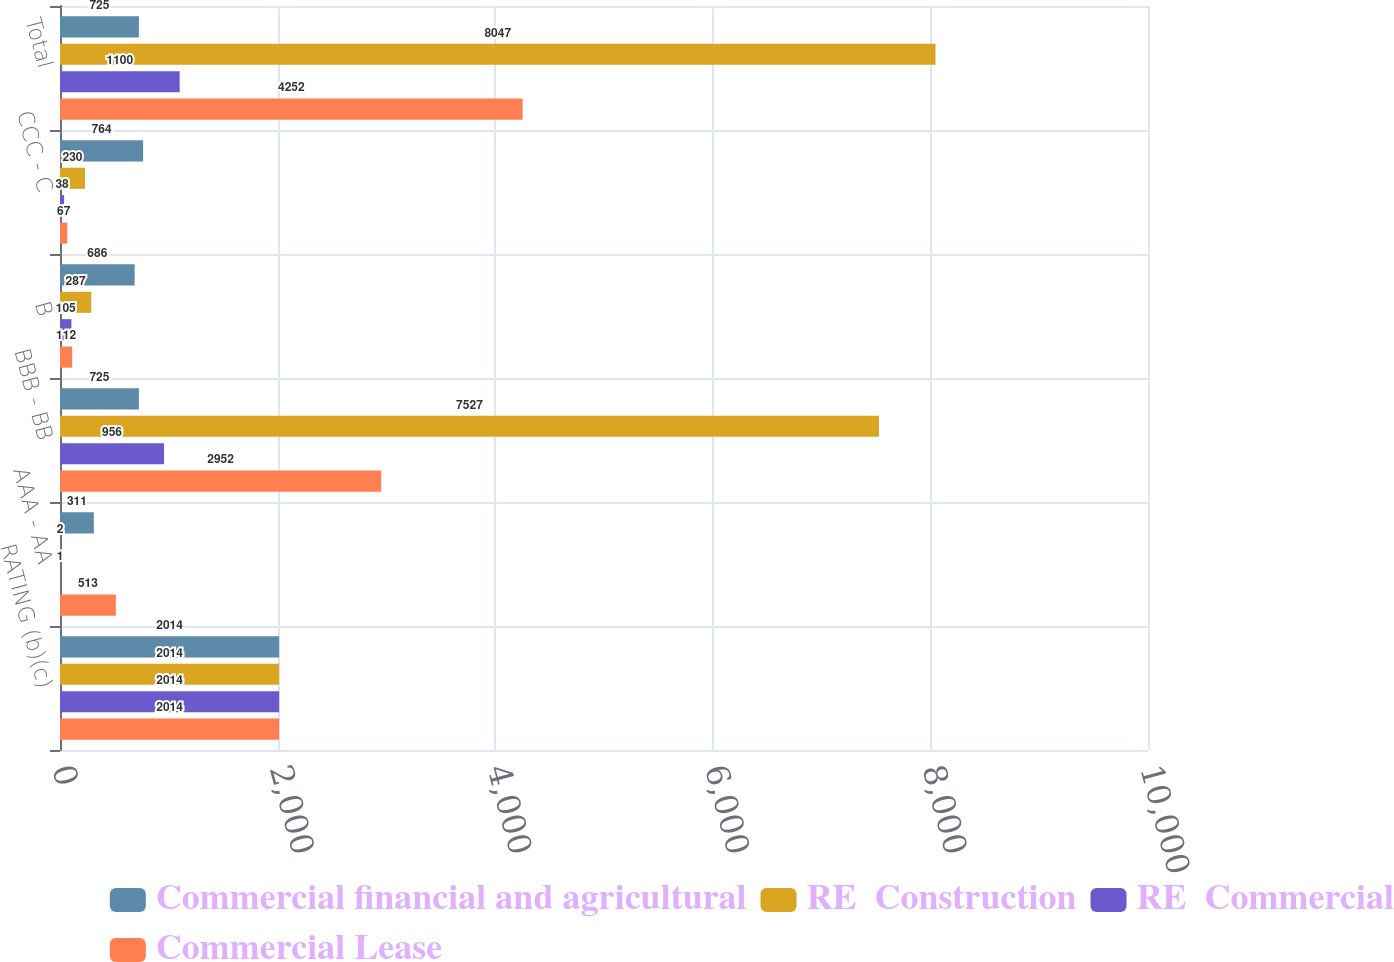<chart> <loc_0><loc_0><loc_500><loc_500><stacked_bar_chart><ecel><fcel>RATING (b)(c)<fcel>AAA - AA<fcel>BBB - BB<fcel>B<fcel>CCC - C<fcel>Total<nl><fcel>Commercial financial and agricultural<fcel>2014<fcel>311<fcel>725<fcel>686<fcel>764<fcel>725<nl><fcel>RE  Construction<fcel>2014<fcel>2<fcel>7527<fcel>287<fcel>230<fcel>8047<nl><fcel>RE  Commercial<fcel>2014<fcel>1<fcel>956<fcel>105<fcel>38<fcel>1100<nl><fcel>Commercial Lease<fcel>2014<fcel>513<fcel>2952<fcel>112<fcel>67<fcel>4252<nl></chart> 